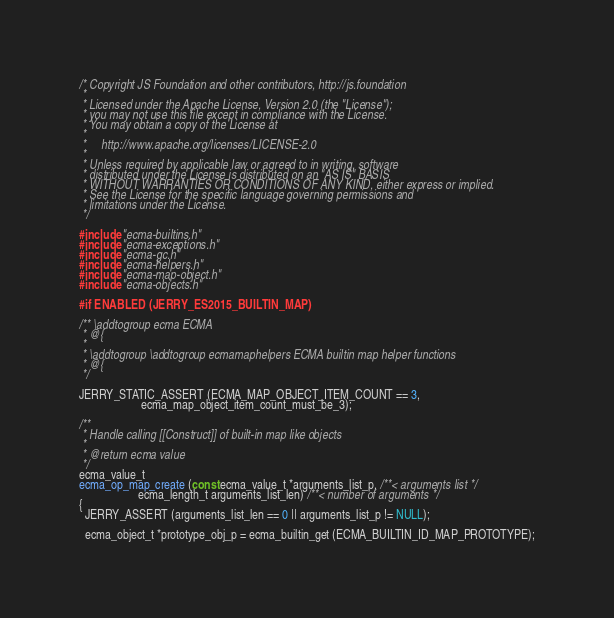<code> <loc_0><loc_0><loc_500><loc_500><_C_>/* Copyright JS Foundation and other contributors, http://js.foundation
 *
 * Licensed under the Apache License, Version 2.0 (the "License");
 * you may not use this file except in compliance with the License.
 * You may obtain a copy of the License at
 *
 *     http://www.apache.org/licenses/LICENSE-2.0
 *
 * Unless required by applicable law or agreed to in writing, software
 * distributed under the License is distributed on an "AS IS" BASIS
 * WITHOUT WARRANTIES OR CONDITIONS OF ANY KIND, either express or implied.
 * See the License for the specific language governing permissions and
 * limitations under the License.
 */

#include "ecma-builtins.h"
#include "ecma-exceptions.h"
#include "ecma-gc.h"
#include "ecma-helpers.h"
#include "ecma-map-object.h"
#include "ecma-objects.h"

#if ENABLED (JERRY_ES2015_BUILTIN_MAP)

/** \addtogroup ecma ECMA
 * @{
 *
 * \addtogroup \addtogroup ecmamaphelpers ECMA builtin map helper functions
 * @{
 */

JERRY_STATIC_ASSERT (ECMA_MAP_OBJECT_ITEM_COUNT == 3,
                     ecma_map_object_item_count_must_be_3);

/**
 * Handle calling [[Construct]] of built-in map like objects
 *
 * @return ecma value
 */
ecma_value_t
ecma_op_map_create (const ecma_value_t *arguments_list_p, /**< arguments list */
                    ecma_length_t arguments_list_len) /**< number of arguments */
{
  JERRY_ASSERT (arguments_list_len == 0 || arguments_list_p != NULL);

  ecma_object_t *prototype_obj_p = ecma_builtin_get (ECMA_BUILTIN_ID_MAP_PROTOTYPE);</code> 